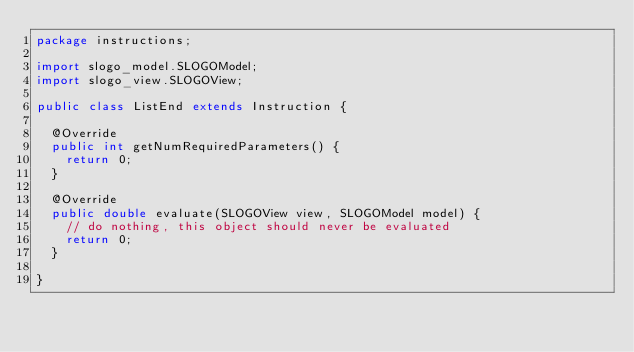Convert code to text. <code><loc_0><loc_0><loc_500><loc_500><_Java_>package instructions;

import slogo_model.SLOGOModel;
import slogo_view.SLOGOView;

public class ListEnd extends Instruction {

	@Override
	public int getNumRequiredParameters() {
		return 0;
	}

	@Override
	public double evaluate(SLOGOView view, SLOGOModel model) {
		// do nothing, this object should never be evaluated
		return 0;
	}

}
</code> 